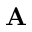<formula> <loc_0><loc_0><loc_500><loc_500>{ A }</formula> 